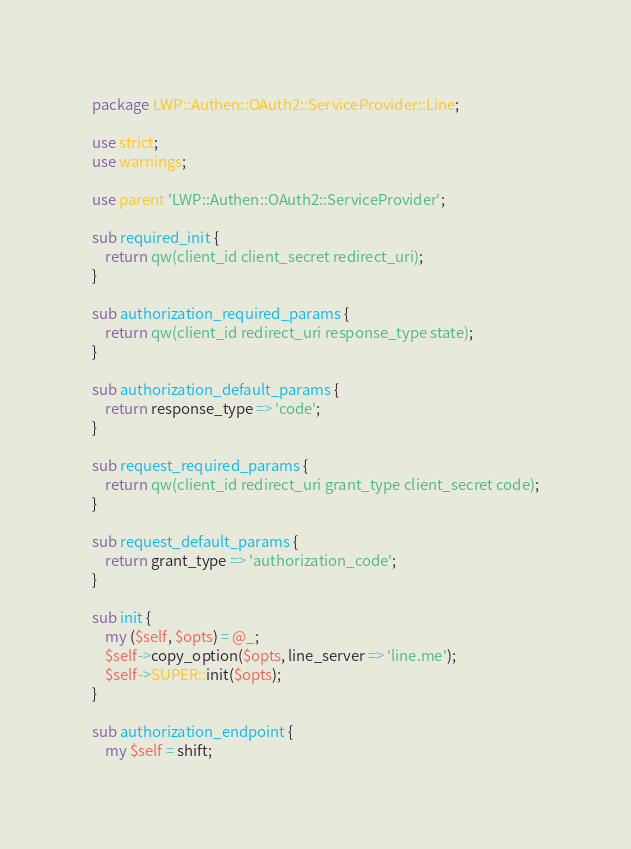<code> <loc_0><loc_0><loc_500><loc_500><_Perl_>package LWP::Authen::OAuth2::ServiceProvider::Line;

use strict;
use warnings;

use parent 'LWP::Authen::OAuth2::ServiceProvider';

sub required_init {
    return qw(client_id client_secret redirect_uri);
}

sub authorization_required_params {
    return qw(client_id redirect_uri response_type state);
}

sub authorization_default_params {
    return response_type => 'code';
}

sub request_required_params {
    return qw(client_id redirect_uri grant_type client_secret code);
}

sub request_default_params {
    return grant_type => 'authorization_code';
}

sub init {
    my ($self, $opts) = @_;
    $self->copy_option($opts, line_server => 'line.me');
    $self->SUPER::init($opts);
}

sub authorization_endpoint {
    my $self = shift;</code> 